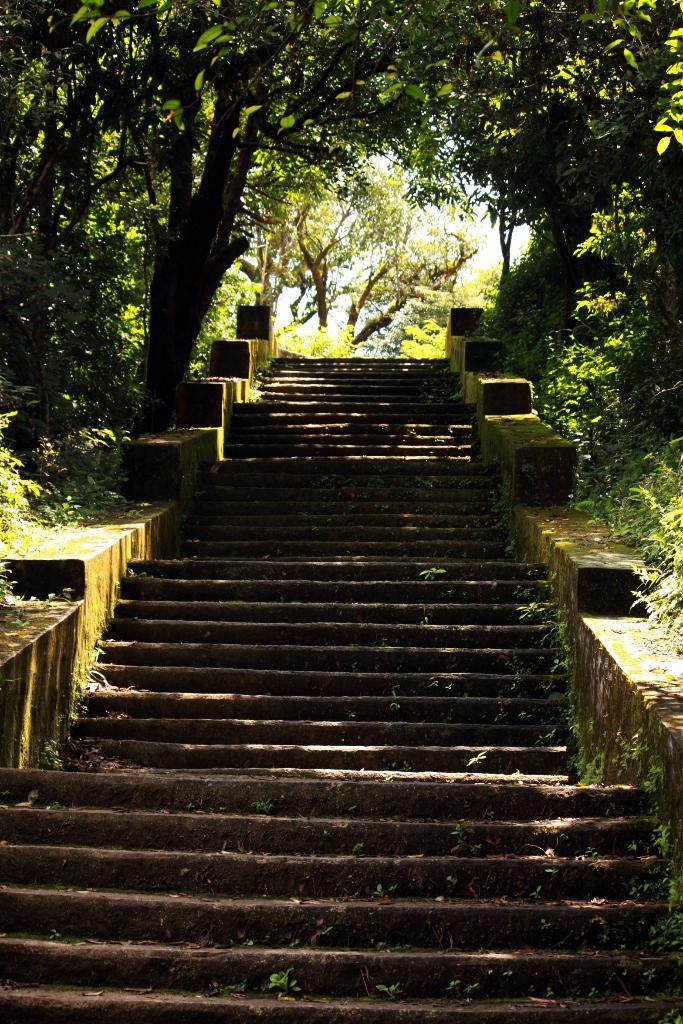What type of structure is present in the image? There are stairs in the image. What type of vegetation can be seen in the image? There are trees with green color in the image. What is the color of the sky in the image? The sky appears to be white in the image. Can you see any ornaments hanging from the trees in the image? There is no mention of ornaments in the image, only trees with green color. Is there a banana tree visible in the image? There is no mention of a banana tree in the image; only trees with green color are described. 